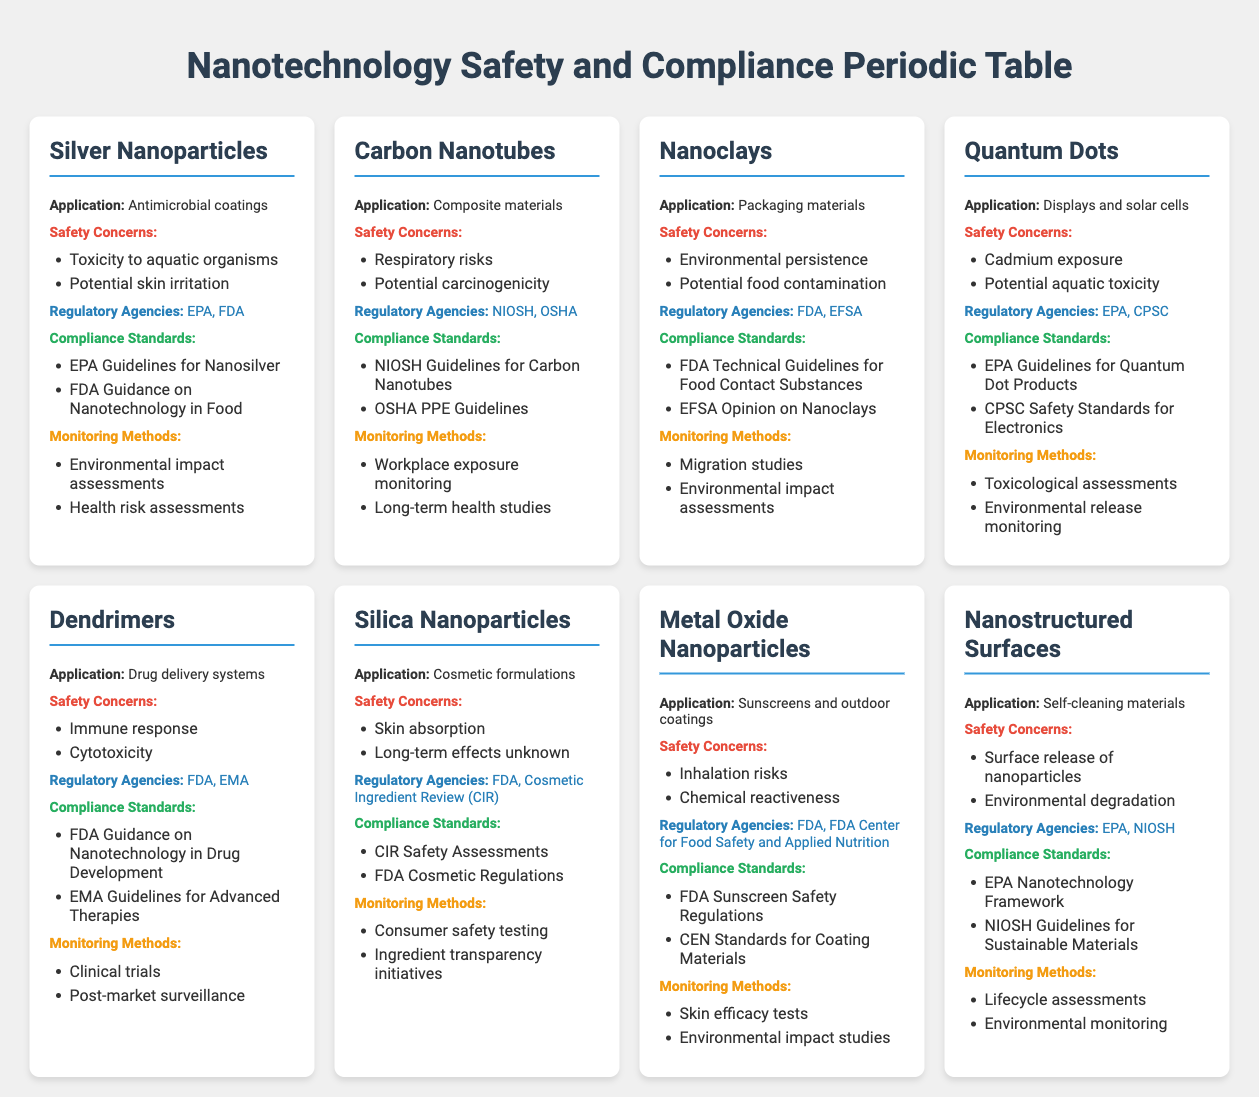What are the safety concerns associated with Silver Nanoparticles? The safety concerns for Silver Nanoparticles, as listed in the table, are toxicity to aquatic organisms and potential skin irritation. These can be found directly in the Silver Nanoparticles section of the table under "Safety Concerns."
Answer: Toxicity to aquatic organisms, potential skin irritation Which regulatory agencies oversee the use of Carbon Nanotubes? The regulatory agencies for Carbon Nanotubes are NIOSH and OSHA. This information is available in the relevant section of the table titled "Regulatory Agencies."
Answer: NIOSH, OSHA Are there any safety concerns for Nanoclays? Yes, Nanoclays have safety concerns, specifically environmental persistence and potential food contamination. These concerns are stated in the Nanoclays section under "Safety Concerns."
Answer: Yes What is the most common type of monitoring method for nanotechnology products based on the table? By reviewing the monitoring methods listed for each product, we find that "Environmental impact assessments" and "Long-term health studies" are mentioned multiple times. This indicates that these methods are commonly used across different nanotechnology products. Thus, the common methods involve environmental and health assessments.
Answer: Environmental impact assessments, long-term health studies How many products have the regulatory agency EPA associated with them? There are four products that list the EPA among their regulatory agencies: Silver Nanoparticles, Quantum Dots, Metal Oxide Nanoparticles, and Nanostructured Surfaces. By reading through the regulatory agencies listed for each product, we can count the occurrences of EPA.
Answer: 4 